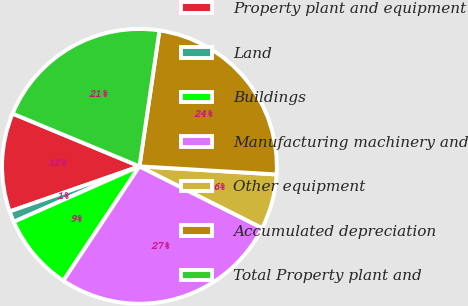<chart> <loc_0><loc_0><loc_500><loc_500><pie_chart><fcel>Property plant and equipment<fcel>Land<fcel>Buildings<fcel>Manufacturing machinery and<fcel>Other equipment<fcel>Accumulated depreciation<fcel>Total Property plant and<nl><fcel>11.6%<fcel>1.29%<fcel>9.04%<fcel>26.93%<fcel>6.47%<fcel>23.61%<fcel>21.05%<nl></chart> 